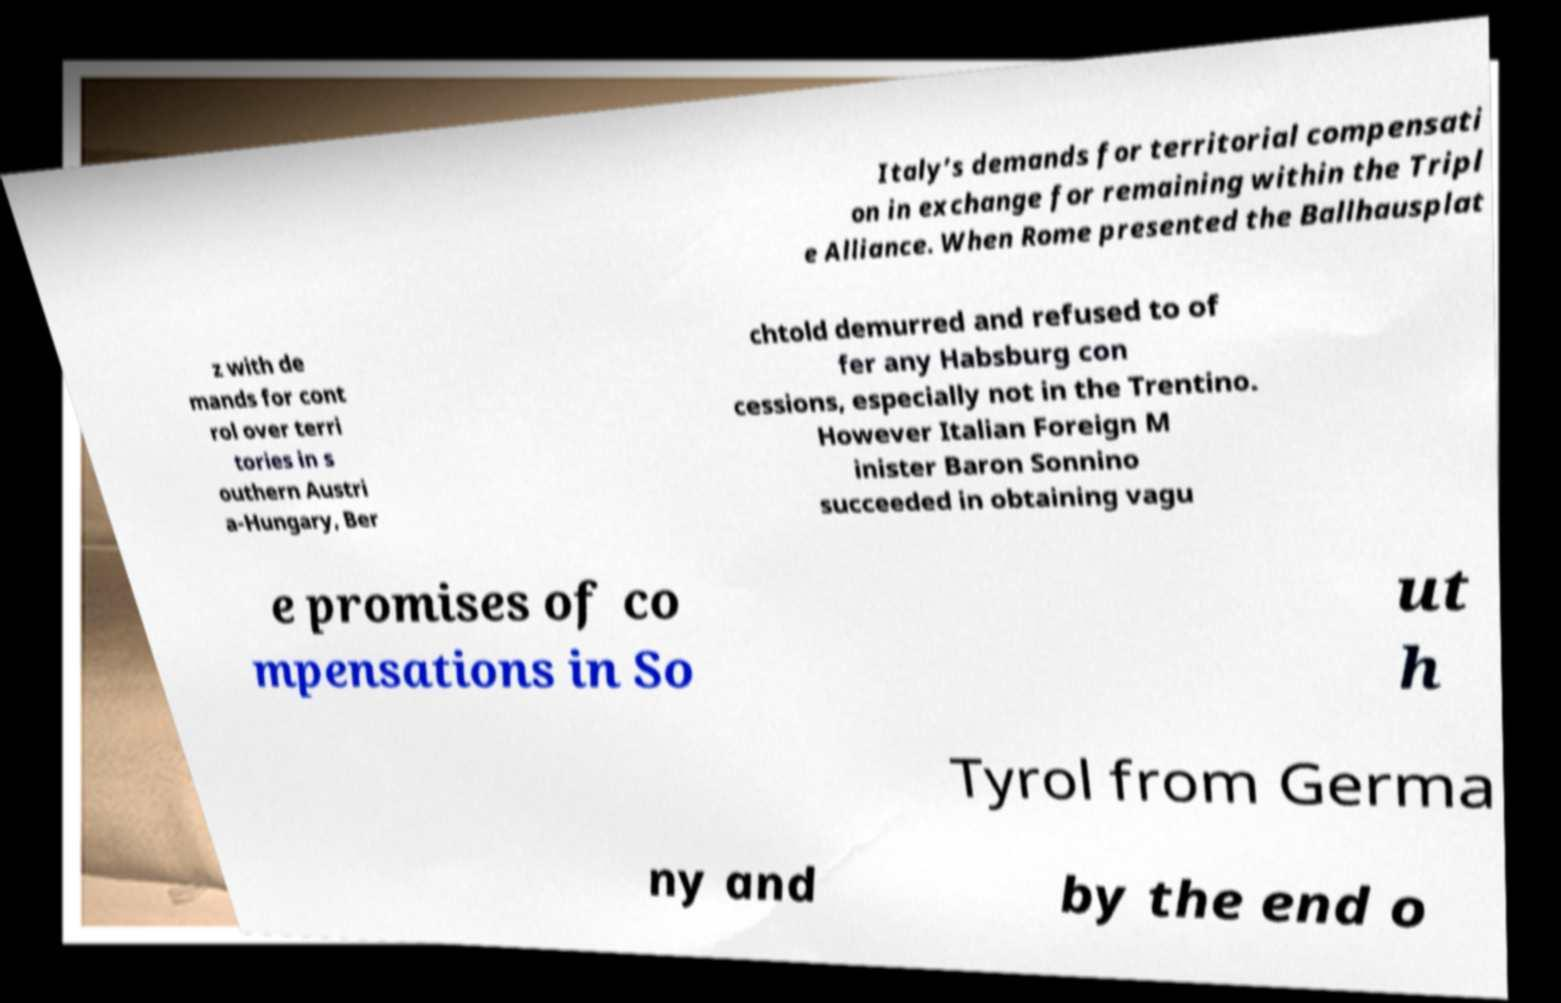There's text embedded in this image that I need extracted. Can you transcribe it verbatim? Italy’s demands for territorial compensati on in exchange for remaining within the Tripl e Alliance. When Rome presented the Ballhausplat z with de mands for cont rol over terri tories in s outhern Austri a-Hungary, Ber chtold demurred and refused to of fer any Habsburg con cessions, especially not in the Trentino. However Italian Foreign M inister Baron Sonnino succeeded in obtaining vagu e promises of co mpensations in So ut h Tyrol from Germa ny and by the end o 